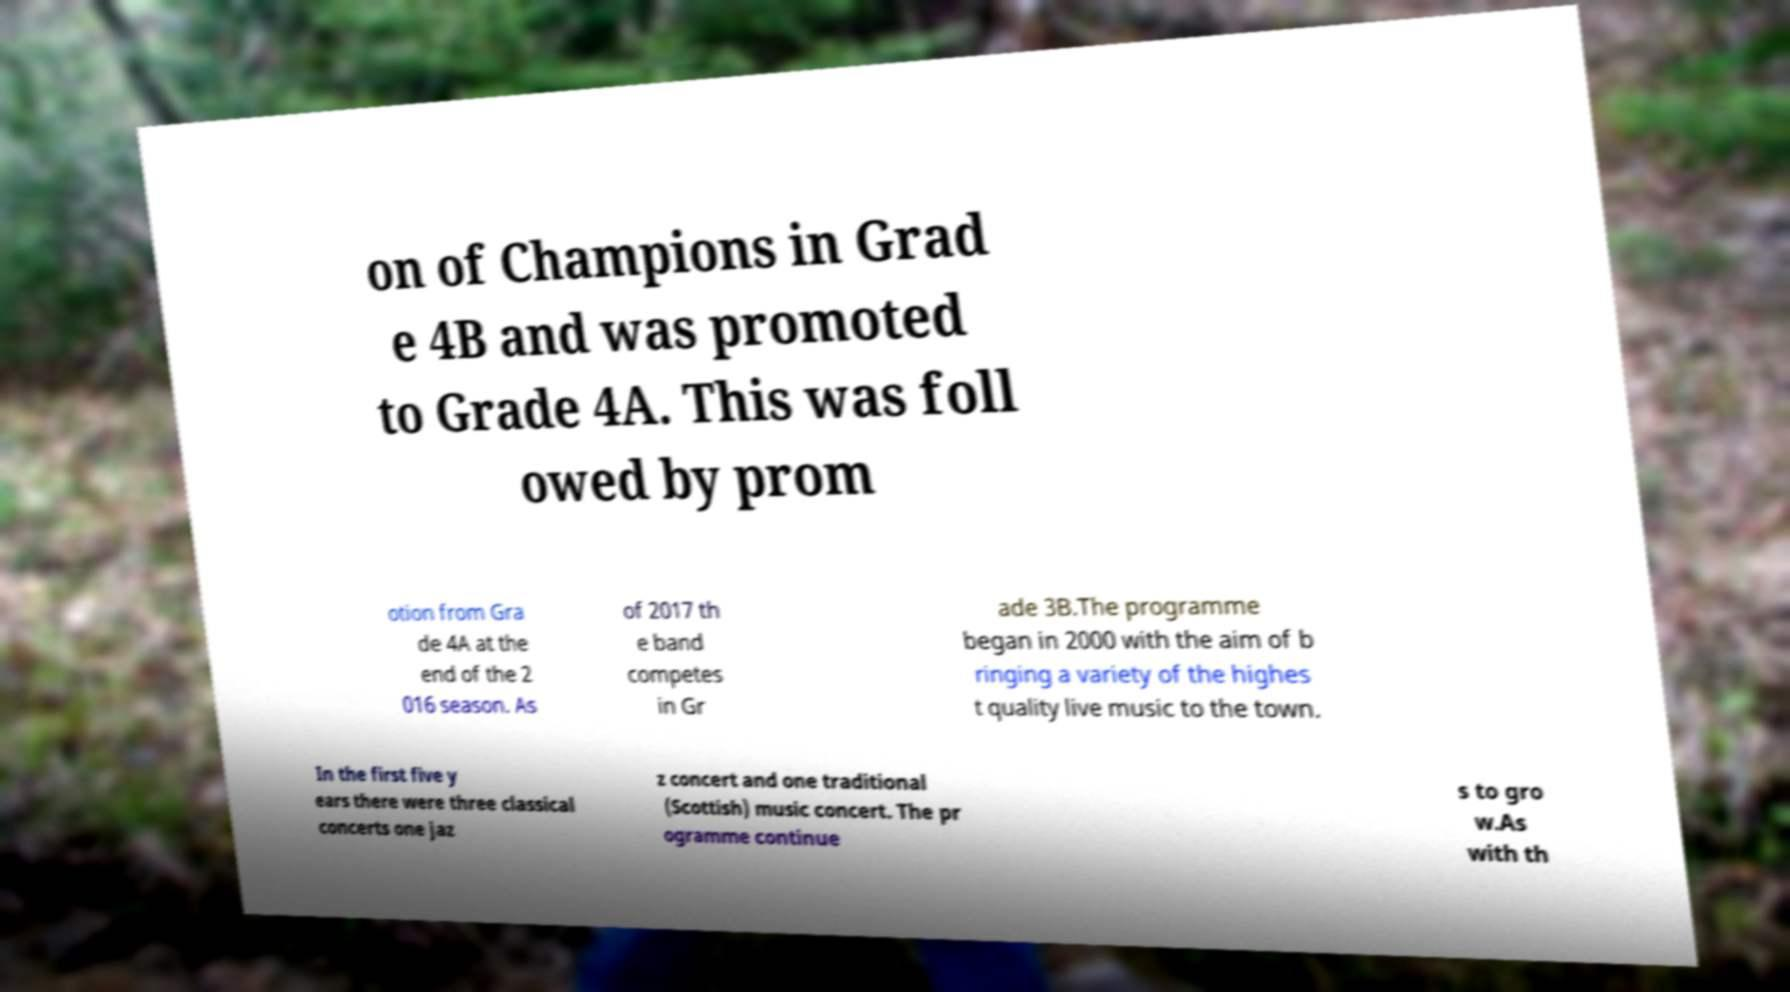Could you assist in decoding the text presented in this image and type it out clearly? on of Champions in Grad e 4B and was promoted to Grade 4A. This was foll owed by prom otion from Gra de 4A at the end of the 2 016 season. As of 2017 th e band competes in Gr ade 3B.The programme began in 2000 with the aim of b ringing a variety of the highes t quality live music to the town. In the first five y ears there were three classical concerts one jaz z concert and one traditional (Scottish) music concert. The pr ogramme continue s to gro w.As with th 